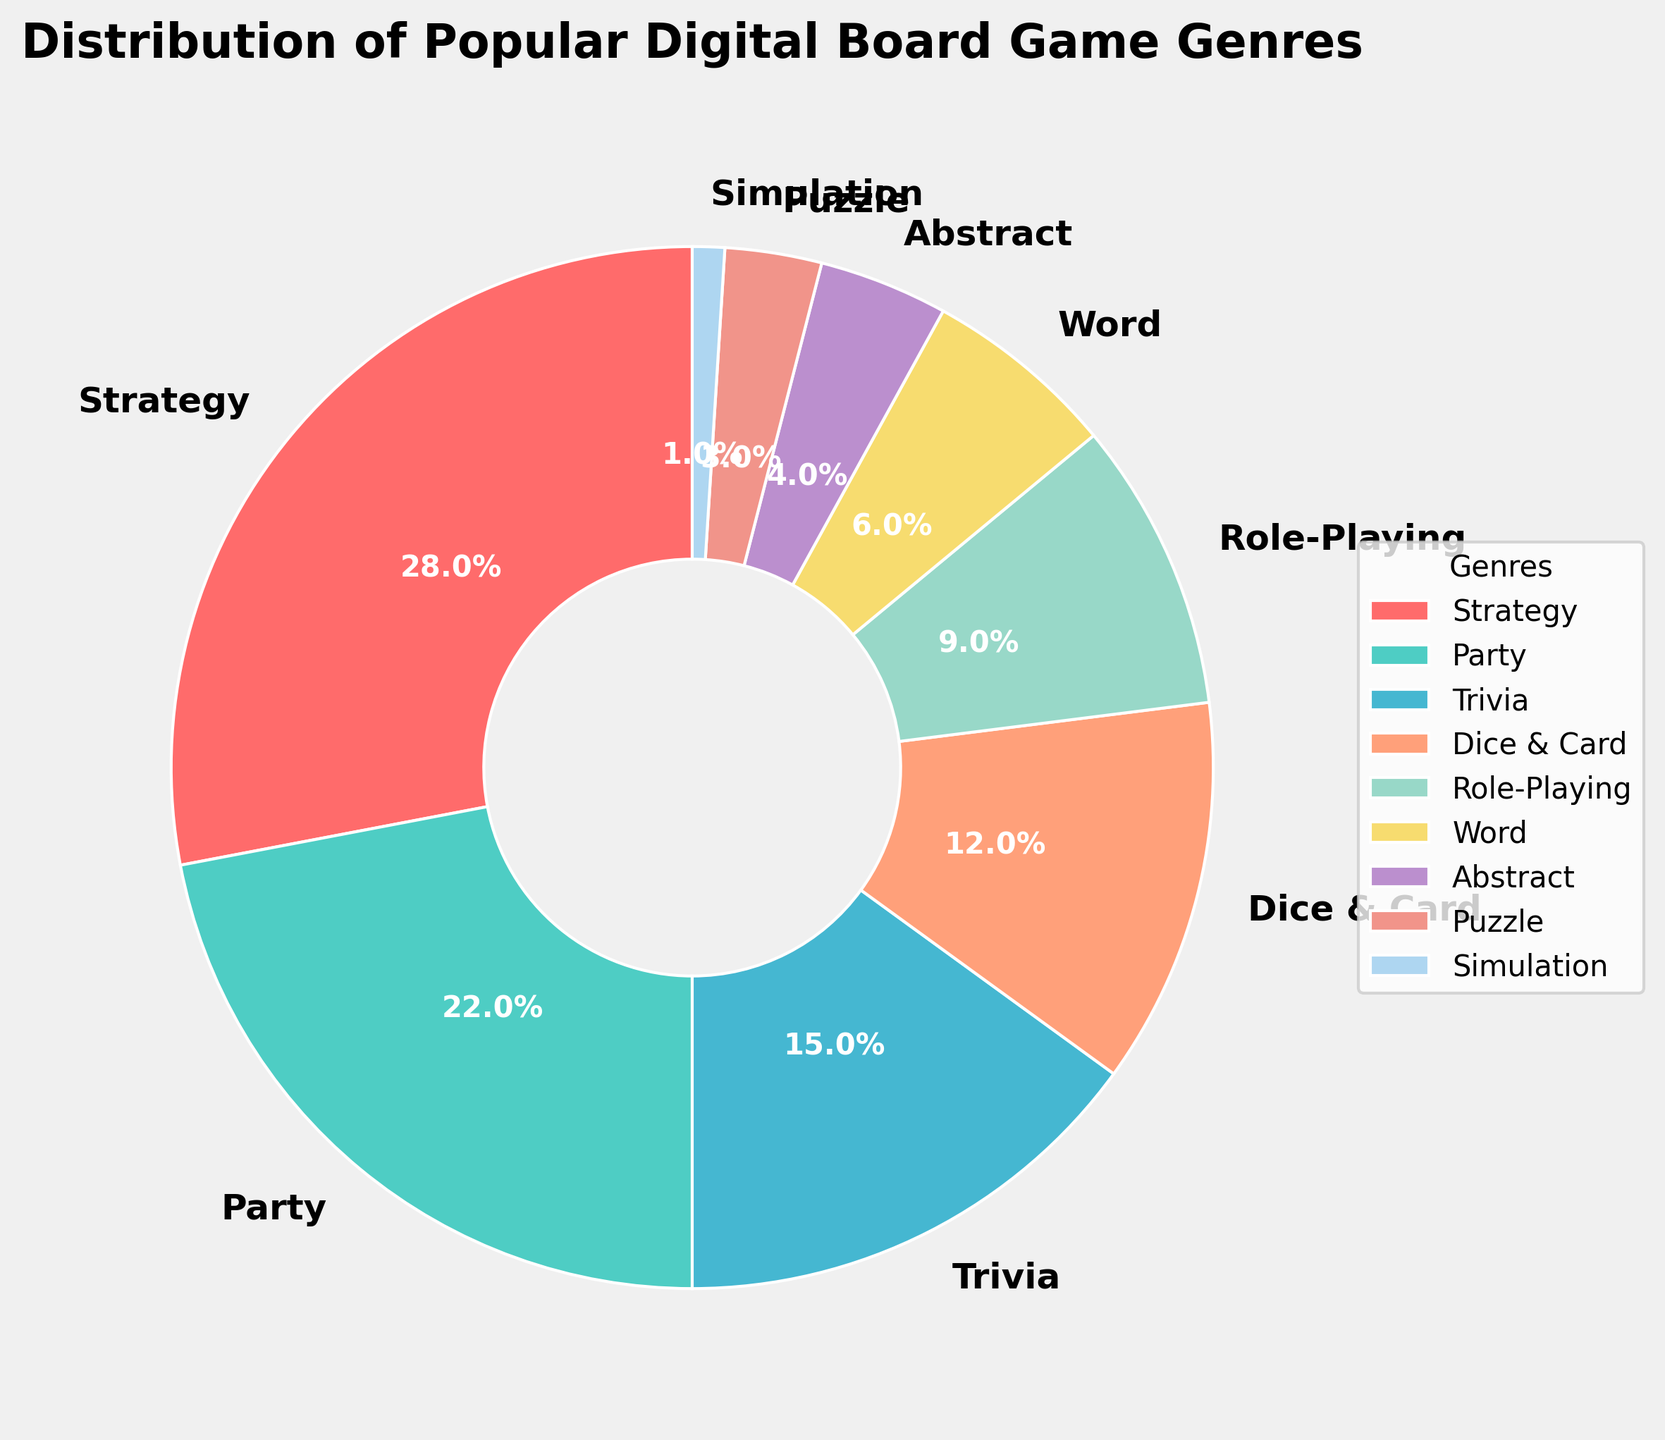What's the most popular genre? The genre with the highest percentage represents the most popular one. By looking at the largest segment, we see that "Strategy" holds the highest percentage.
Answer: Strategy What's the combined percentage of Trivia and Dice & Card genres? We need to add the percentages for Trivia and Dice & Card shown in the pie chart. Trivia is 15% and Dice & Card is 12%, so the sum is 15% + 12% = 27%.
Answer: 27% Which genres have a percentage less than 10%? By examining the segments less than 10%, we can list them: Role-Playing (9%), Word (6%), Abstract (4%), Puzzle (3%), and Simulation (1%).
Answer: Role-Playing, Word, Abstract, Puzzle, Simulation Is the percentage of Party games greater than Dice & Card games? We compare the percentages for Party and Dice & Card. Party is 22% and Dice & Card is 12%. 22% is greater than 12%.
Answer: Yes How much more popular are Strategy games compared to Role-Playing games? We subtract the percentage of Role-Playing from Strategy to find how much more popular it is. Strategy is 28% and Role-Playing is 9%. Therefore, 28% - 9% = 19%.
Answer: 19% What percentage of the genres have a percentage above 20%? We count the genres with percentages above 20%. Only Strategy (28%) and Party (22%) are above 20%. So, 2 out of 9 genres. (2/9) * 100 = 22.2%.
Answer: 22.2% Which genre is represented by the dark blue segment? By observing the colors and matching them to the legends, the dark blue segment corresponds to "Word" games.
Answer: Word What is the difference in percentage between the most and least popular genres? Subtract the percentage of the least popular genre (Simulation, 1%) from the most popular genre (Strategy, 28%). 28% - 1% = 27%.
Answer: 27% Is the percentage of Puzzle games closer to Dice & Card games or Word games? We find the absolute differences: Dice & Card (12%) - Puzzle (3%) = 9%; Word (6%) - Puzzle (3%) = 3%. The smallest difference is with Word games.
Answer: Word games How many genres have a percentage that adds up to more than 50%? Adding up percentages smallest to largest: Simulation (1%) + Puzzle (3%) + Abstract (4%) + Word (6%) + Role-Playing (9%) + Dice & Card (12%) + Trivia (15%) = 50% (7 genres, but as soon as we add another genre, we exceed 50%). Hence, 2 genres like Strategy and Party alone are above 50%.
Answer: 2 genres 